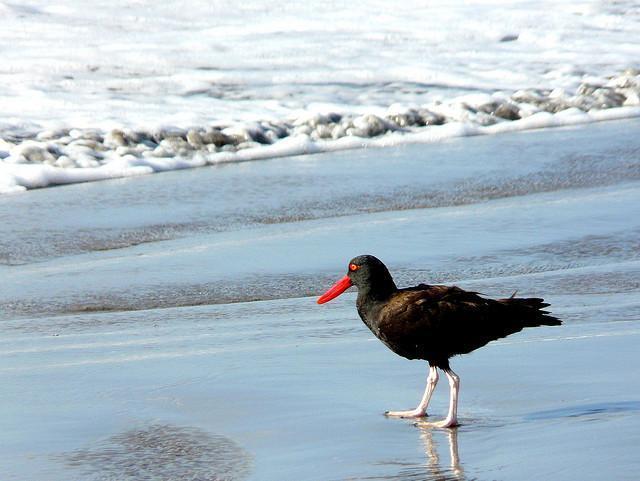How many cows are walking in the road?
Give a very brief answer. 0. 